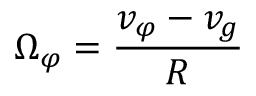Convert formula to latex. <formula><loc_0><loc_0><loc_500><loc_500>\Omega _ { \varphi } = \frac { v _ { \varphi } - v _ { g } } { R }</formula> 